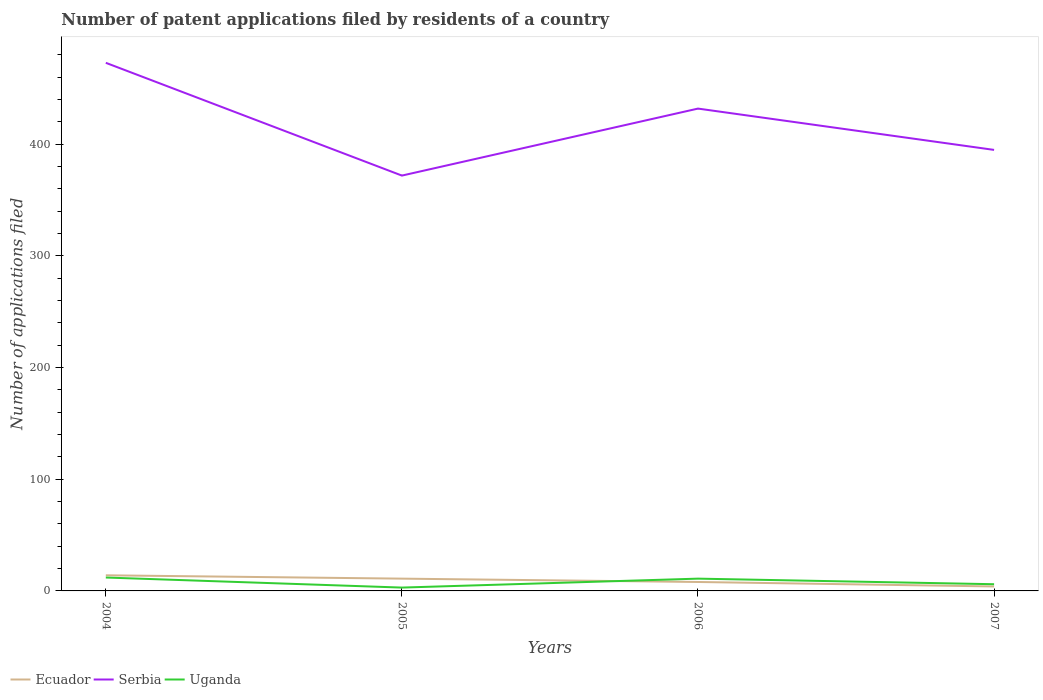How many different coloured lines are there?
Provide a short and direct response. 3. Does the line corresponding to Serbia intersect with the line corresponding to Ecuador?
Make the answer very short. No. Is the number of lines equal to the number of legend labels?
Make the answer very short. Yes. In which year was the number of applications filed in Serbia maximum?
Provide a succinct answer. 2005. What is the total number of applications filed in Ecuador in the graph?
Offer a very short reply. 10. What is the difference between the highest and the second highest number of applications filed in Serbia?
Your response must be concise. 101. How many years are there in the graph?
Provide a short and direct response. 4. What is the difference between two consecutive major ticks on the Y-axis?
Your response must be concise. 100. Does the graph contain any zero values?
Provide a short and direct response. No. Does the graph contain grids?
Make the answer very short. No. How many legend labels are there?
Your answer should be very brief. 3. What is the title of the graph?
Keep it short and to the point. Number of patent applications filed by residents of a country. Does "Denmark" appear as one of the legend labels in the graph?
Ensure brevity in your answer.  No. What is the label or title of the X-axis?
Your answer should be compact. Years. What is the label or title of the Y-axis?
Provide a short and direct response. Number of applications filed. What is the Number of applications filed of Serbia in 2004?
Give a very brief answer. 473. What is the Number of applications filed of Serbia in 2005?
Your response must be concise. 372. What is the Number of applications filed in Uganda in 2005?
Your response must be concise. 3. What is the Number of applications filed in Serbia in 2006?
Make the answer very short. 432. What is the Number of applications filed in Ecuador in 2007?
Offer a terse response. 4. What is the Number of applications filed in Serbia in 2007?
Keep it short and to the point. 395. Across all years, what is the maximum Number of applications filed in Ecuador?
Make the answer very short. 14. Across all years, what is the maximum Number of applications filed in Serbia?
Ensure brevity in your answer.  473. Across all years, what is the minimum Number of applications filed of Ecuador?
Your answer should be compact. 4. Across all years, what is the minimum Number of applications filed of Serbia?
Your answer should be very brief. 372. Across all years, what is the minimum Number of applications filed of Uganda?
Your response must be concise. 3. What is the total Number of applications filed in Ecuador in the graph?
Offer a very short reply. 37. What is the total Number of applications filed of Serbia in the graph?
Provide a succinct answer. 1672. What is the difference between the Number of applications filed of Ecuador in 2004 and that in 2005?
Make the answer very short. 3. What is the difference between the Number of applications filed of Serbia in 2004 and that in 2005?
Provide a succinct answer. 101. What is the difference between the Number of applications filed of Ecuador in 2004 and that in 2006?
Provide a short and direct response. 6. What is the difference between the Number of applications filed of Serbia in 2004 and that in 2006?
Provide a succinct answer. 41. What is the difference between the Number of applications filed in Uganda in 2004 and that in 2006?
Offer a very short reply. 1. What is the difference between the Number of applications filed in Uganda in 2004 and that in 2007?
Provide a succinct answer. 6. What is the difference between the Number of applications filed of Ecuador in 2005 and that in 2006?
Give a very brief answer. 3. What is the difference between the Number of applications filed of Serbia in 2005 and that in 2006?
Your answer should be compact. -60. What is the difference between the Number of applications filed in Uganda in 2005 and that in 2007?
Keep it short and to the point. -3. What is the difference between the Number of applications filed in Serbia in 2006 and that in 2007?
Ensure brevity in your answer.  37. What is the difference between the Number of applications filed in Ecuador in 2004 and the Number of applications filed in Serbia in 2005?
Provide a short and direct response. -358. What is the difference between the Number of applications filed in Ecuador in 2004 and the Number of applications filed in Uganda in 2005?
Your answer should be very brief. 11. What is the difference between the Number of applications filed in Serbia in 2004 and the Number of applications filed in Uganda in 2005?
Your answer should be very brief. 470. What is the difference between the Number of applications filed of Ecuador in 2004 and the Number of applications filed of Serbia in 2006?
Give a very brief answer. -418. What is the difference between the Number of applications filed in Serbia in 2004 and the Number of applications filed in Uganda in 2006?
Ensure brevity in your answer.  462. What is the difference between the Number of applications filed in Ecuador in 2004 and the Number of applications filed in Serbia in 2007?
Provide a succinct answer. -381. What is the difference between the Number of applications filed of Ecuador in 2004 and the Number of applications filed of Uganda in 2007?
Give a very brief answer. 8. What is the difference between the Number of applications filed of Serbia in 2004 and the Number of applications filed of Uganda in 2007?
Your response must be concise. 467. What is the difference between the Number of applications filed of Ecuador in 2005 and the Number of applications filed of Serbia in 2006?
Keep it short and to the point. -421. What is the difference between the Number of applications filed of Ecuador in 2005 and the Number of applications filed of Uganda in 2006?
Your answer should be very brief. 0. What is the difference between the Number of applications filed in Serbia in 2005 and the Number of applications filed in Uganda in 2006?
Give a very brief answer. 361. What is the difference between the Number of applications filed of Ecuador in 2005 and the Number of applications filed of Serbia in 2007?
Provide a succinct answer. -384. What is the difference between the Number of applications filed in Ecuador in 2005 and the Number of applications filed in Uganda in 2007?
Your answer should be compact. 5. What is the difference between the Number of applications filed of Serbia in 2005 and the Number of applications filed of Uganda in 2007?
Offer a terse response. 366. What is the difference between the Number of applications filed in Ecuador in 2006 and the Number of applications filed in Serbia in 2007?
Ensure brevity in your answer.  -387. What is the difference between the Number of applications filed of Ecuador in 2006 and the Number of applications filed of Uganda in 2007?
Offer a very short reply. 2. What is the difference between the Number of applications filed in Serbia in 2006 and the Number of applications filed in Uganda in 2007?
Provide a short and direct response. 426. What is the average Number of applications filed in Ecuador per year?
Your response must be concise. 9.25. What is the average Number of applications filed in Serbia per year?
Offer a very short reply. 418. In the year 2004, what is the difference between the Number of applications filed of Ecuador and Number of applications filed of Serbia?
Your answer should be very brief. -459. In the year 2004, what is the difference between the Number of applications filed of Ecuador and Number of applications filed of Uganda?
Your answer should be very brief. 2. In the year 2004, what is the difference between the Number of applications filed of Serbia and Number of applications filed of Uganda?
Provide a succinct answer. 461. In the year 2005, what is the difference between the Number of applications filed of Ecuador and Number of applications filed of Serbia?
Make the answer very short. -361. In the year 2005, what is the difference between the Number of applications filed in Serbia and Number of applications filed in Uganda?
Give a very brief answer. 369. In the year 2006, what is the difference between the Number of applications filed in Ecuador and Number of applications filed in Serbia?
Ensure brevity in your answer.  -424. In the year 2006, what is the difference between the Number of applications filed of Serbia and Number of applications filed of Uganda?
Your answer should be very brief. 421. In the year 2007, what is the difference between the Number of applications filed of Ecuador and Number of applications filed of Serbia?
Your answer should be compact. -391. In the year 2007, what is the difference between the Number of applications filed of Serbia and Number of applications filed of Uganda?
Keep it short and to the point. 389. What is the ratio of the Number of applications filed in Ecuador in 2004 to that in 2005?
Provide a short and direct response. 1.27. What is the ratio of the Number of applications filed of Serbia in 2004 to that in 2005?
Your answer should be compact. 1.27. What is the ratio of the Number of applications filed in Ecuador in 2004 to that in 2006?
Give a very brief answer. 1.75. What is the ratio of the Number of applications filed of Serbia in 2004 to that in 2006?
Offer a terse response. 1.09. What is the ratio of the Number of applications filed in Serbia in 2004 to that in 2007?
Make the answer very short. 1.2. What is the ratio of the Number of applications filed of Uganda in 2004 to that in 2007?
Make the answer very short. 2. What is the ratio of the Number of applications filed in Ecuador in 2005 to that in 2006?
Your answer should be very brief. 1.38. What is the ratio of the Number of applications filed of Serbia in 2005 to that in 2006?
Ensure brevity in your answer.  0.86. What is the ratio of the Number of applications filed in Uganda in 2005 to that in 2006?
Your answer should be very brief. 0.27. What is the ratio of the Number of applications filed of Ecuador in 2005 to that in 2007?
Make the answer very short. 2.75. What is the ratio of the Number of applications filed in Serbia in 2005 to that in 2007?
Give a very brief answer. 0.94. What is the ratio of the Number of applications filed of Uganda in 2005 to that in 2007?
Your answer should be very brief. 0.5. What is the ratio of the Number of applications filed in Serbia in 2006 to that in 2007?
Provide a short and direct response. 1.09. What is the ratio of the Number of applications filed of Uganda in 2006 to that in 2007?
Give a very brief answer. 1.83. What is the difference between the highest and the second highest Number of applications filed of Ecuador?
Provide a short and direct response. 3. What is the difference between the highest and the second highest Number of applications filed in Serbia?
Make the answer very short. 41. What is the difference between the highest and the second highest Number of applications filed in Uganda?
Keep it short and to the point. 1. What is the difference between the highest and the lowest Number of applications filed of Serbia?
Offer a terse response. 101. What is the difference between the highest and the lowest Number of applications filed of Uganda?
Your answer should be very brief. 9. 